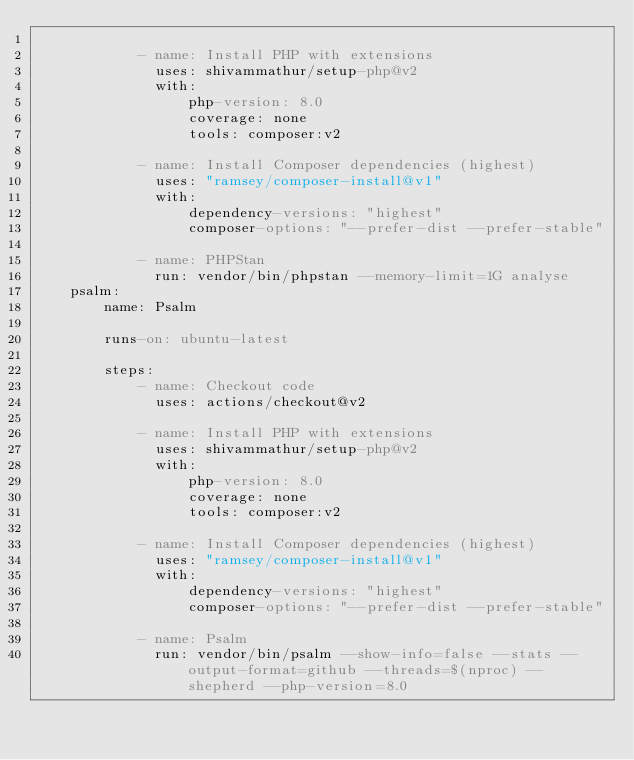Convert code to text. <code><loc_0><loc_0><loc_500><loc_500><_YAML_>
            - name: Install PHP with extensions
              uses: shivammathur/setup-php@v2
              with:
                  php-version: 8.0
                  coverage: none
                  tools: composer:v2

            - name: Install Composer dependencies (highest)
              uses: "ramsey/composer-install@v1"
              with:
                  dependency-versions: "highest"
                  composer-options: "--prefer-dist --prefer-stable"

            - name: PHPStan
              run: vendor/bin/phpstan --memory-limit=1G analyse
    psalm:
        name: Psalm

        runs-on: ubuntu-latest

        steps:
            - name: Checkout code
              uses: actions/checkout@v2

            - name: Install PHP with extensions
              uses: shivammathur/setup-php@v2
              with:
                  php-version: 8.0
                  coverage: none
                  tools: composer:v2

            - name: Install Composer dependencies (highest)
              uses: "ramsey/composer-install@v1"
              with:
                  dependency-versions: "highest"
                  composer-options: "--prefer-dist --prefer-stable"

            - name: Psalm
              run: vendor/bin/psalm --show-info=false --stats --output-format=github --threads=$(nproc) --shepherd --php-version=8.0
</code> 